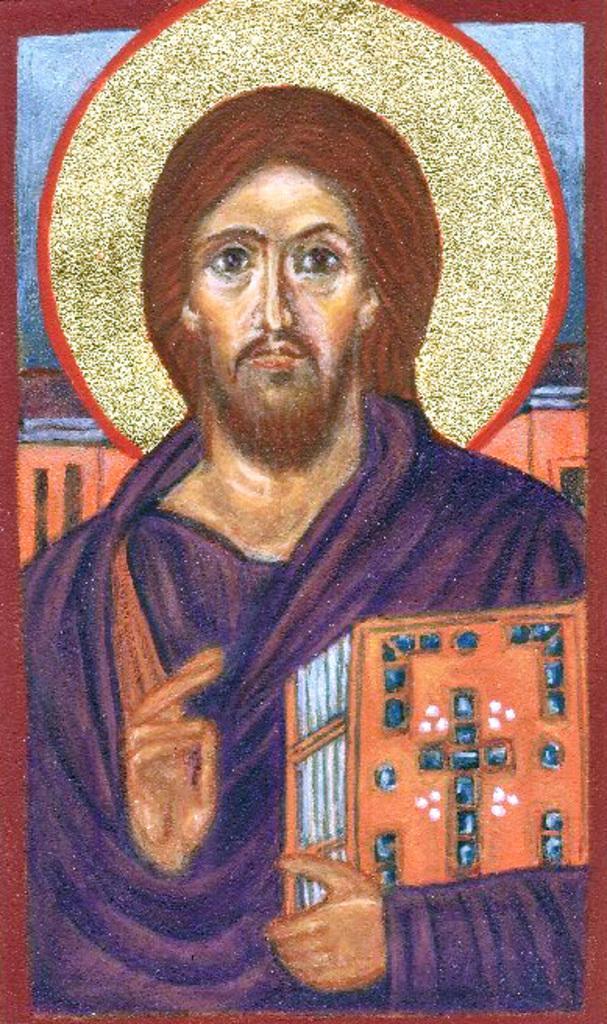Describe this image in one or two sentences. In this image we can see the painting of a man holding book in his hand. 